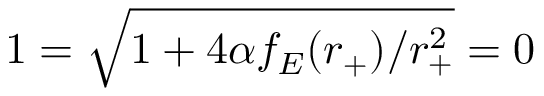<formula> <loc_0><loc_0><loc_500><loc_500>1 = \sqrt { 1 + 4 \alpha f _ { E } ( r _ { + } ) / r _ { + } ^ { 2 } } = 0</formula> 